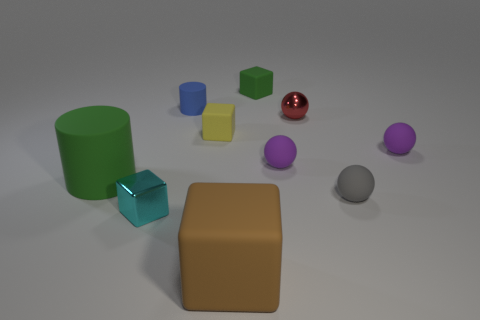Subtract all green cubes. How many cubes are left? 3 Subtract all cylinders. How many objects are left? 8 Subtract all metal objects. Subtract all large brown rubber cubes. How many objects are left? 7 Add 4 red shiny objects. How many red shiny objects are left? 5 Add 6 tiny shiny spheres. How many tiny shiny spheres exist? 7 Subtract all green cubes. How many cubes are left? 3 Subtract 0 gray cylinders. How many objects are left? 10 Subtract 2 cylinders. How many cylinders are left? 0 Subtract all brown spheres. Subtract all gray blocks. How many spheres are left? 4 Subtract all red cylinders. How many cyan spheres are left? 0 